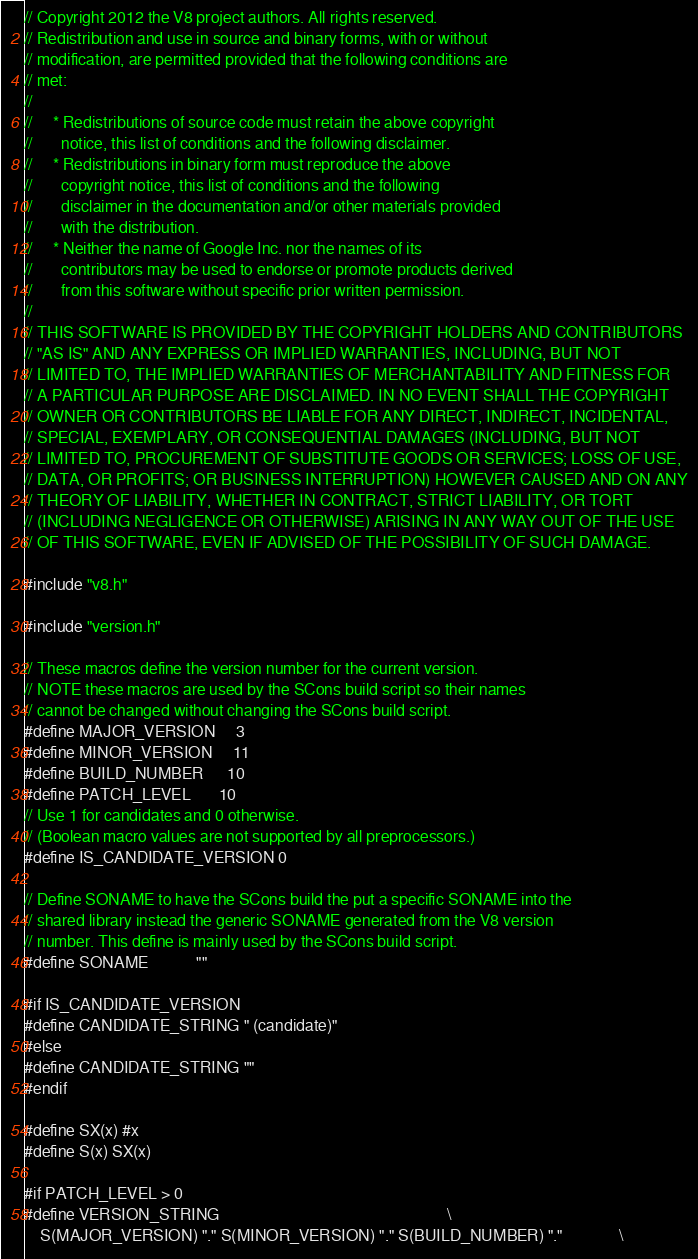<code> <loc_0><loc_0><loc_500><loc_500><_C++_>// Copyright 2012 the V8 project authors. All rights reserved.
// Redistribution and use in source and binary forms, with or without
// modification, are permitted provided that the following conditions are
// met:
//
//     * Redistributions of source code must retain the above copyright
//       notice, this list of conditions and the following disclaimer.
//     * Redistributions in binary form must reproduce the above
//       copyright notice, this list of conditions and the following
//       disclaimer in the documentation and/or other materials provided
//       with the distribution.
//     * Neither the name of Google Inc. nor the names of its
//       contributors may be used to endorse or promote products derived
//       from this software without specific prior written permission.
//
// THIS SOFTWARE IS PROVIDED BY THE COPYRIGHT HOLDERS AND CONTRIBUTORS
// "AS IS" AND ANY EXPRESS OR IMPLIED WARRANTIES, INCLUDING, BUT NOT
// LIMITED TO, THE IMPLIED WARRANTIES OF MERCHANTABILITY AND FITNESS FOR
// A PARTICULAR PURPOSE ARE DISCLAIMED. IN NO EVENT SHALL THE COPYRIGHT
// OWNER OR CONTRIBUTORS BE LIABLE FOR ANY DIRECT, INDIRECT, INCIDENTAL,
// SPECIAL, EXEMPLARY, OR CONSEQUENTIAL DAMAGES (INCLUDING, BUT NOT
// LIMITED TO, PROCUREMENT OF SUBSTITUTE GOODS OR SERVICES; LOSS OF USE,
// DATA, OR PROFITS; OR BUSINESS INTERRUPTION) HOWEVER CAUSED AND ON ANY
// THEORY OF LIABILITY, WHETHER IN CONTRACT, STRICT LIABILITY, OR TORT
// (INCLUDING NEGLIGENCE OR OTHERWISE) ARISING IN ANY WAY OUT OF THE USE
// OF THIS SOFTWARE, EVEN IF ADVISED OF THE POSSIBILITY OF SUCH DAMAGE.

#include "v8.h"

#include "version.h"

// These macros define the version number for the current version.
// NOTE these macros are used by the SCons build script so their names
// cannot be changed without changing the SCons build script.
#define MAJOR_VERSION     3
#define MINOR_VERSION     11
#define BUILD_NUMBER      10
#define PATCH_LEVEL       10
// Use 1 for candidates and 0 otherwise.
// (Boolean macro values are not supported by all preprocessors.)
#define IS_CANDIDATE_VERSION 0

// Define SONAME to have the SCons build the put a specific SONAME into the
// shared library instead the generic SONAME generated from the V8 version
// number. This define is mainly used by the SCons build script.
#define SONAME            ""

#if IS_CANDIDATE_VERSION
#define CANDIDATE_STRING " (candidate)"
#else
#define CANDIDATE_STRING ""
#endif

#define SX(x) #x
#define S(x) SX(x)

#if PATCH_LEVEL > 0
#define VERSION_STRING                                                         \
    S(MAJOR_VERSION) "." S(MINOR_VERSION) "." S(BUILD_NUMBER) "."              \</code> 